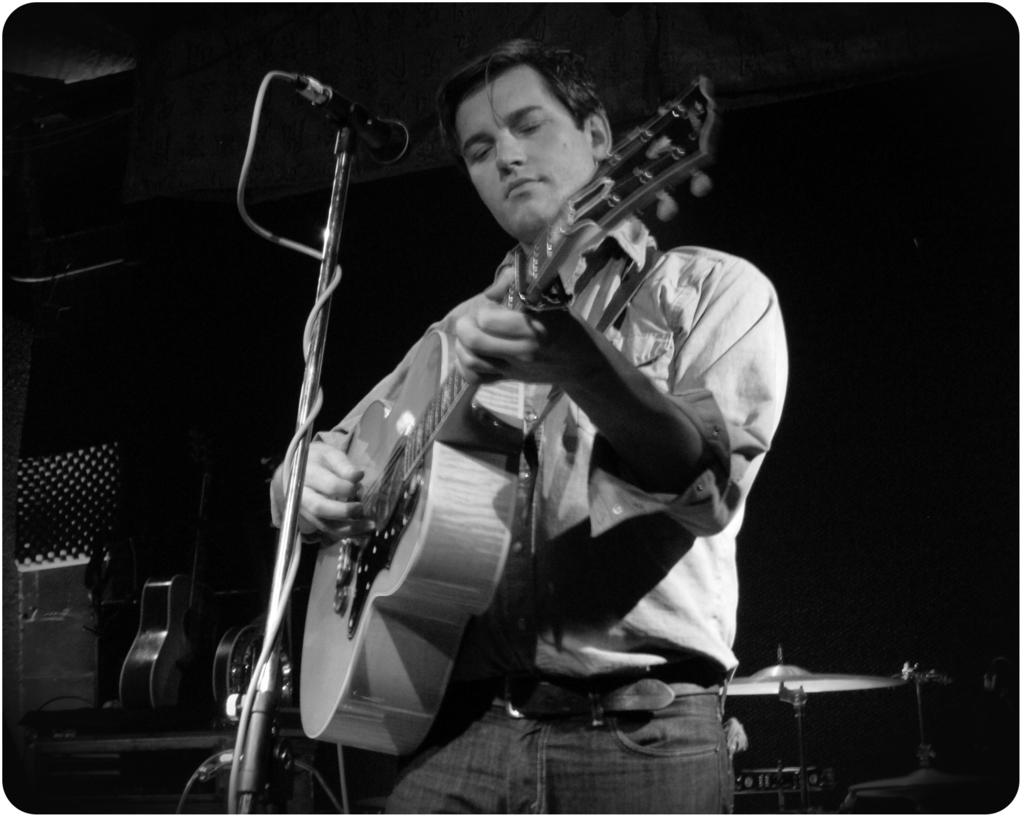What is the color scheme of the image? The image is black and white. What is the person in the image doing? The person is holding a guitar and playing it. What object is in front of the person? There is a mic stand in front of the person. What other guitar can be seen in the image? There is a guitar in the background of the image. How many cows are visible in the image? There are no cows present in the image. What type of education is being provided in the image? There is no indication of any educational activity in the image. 